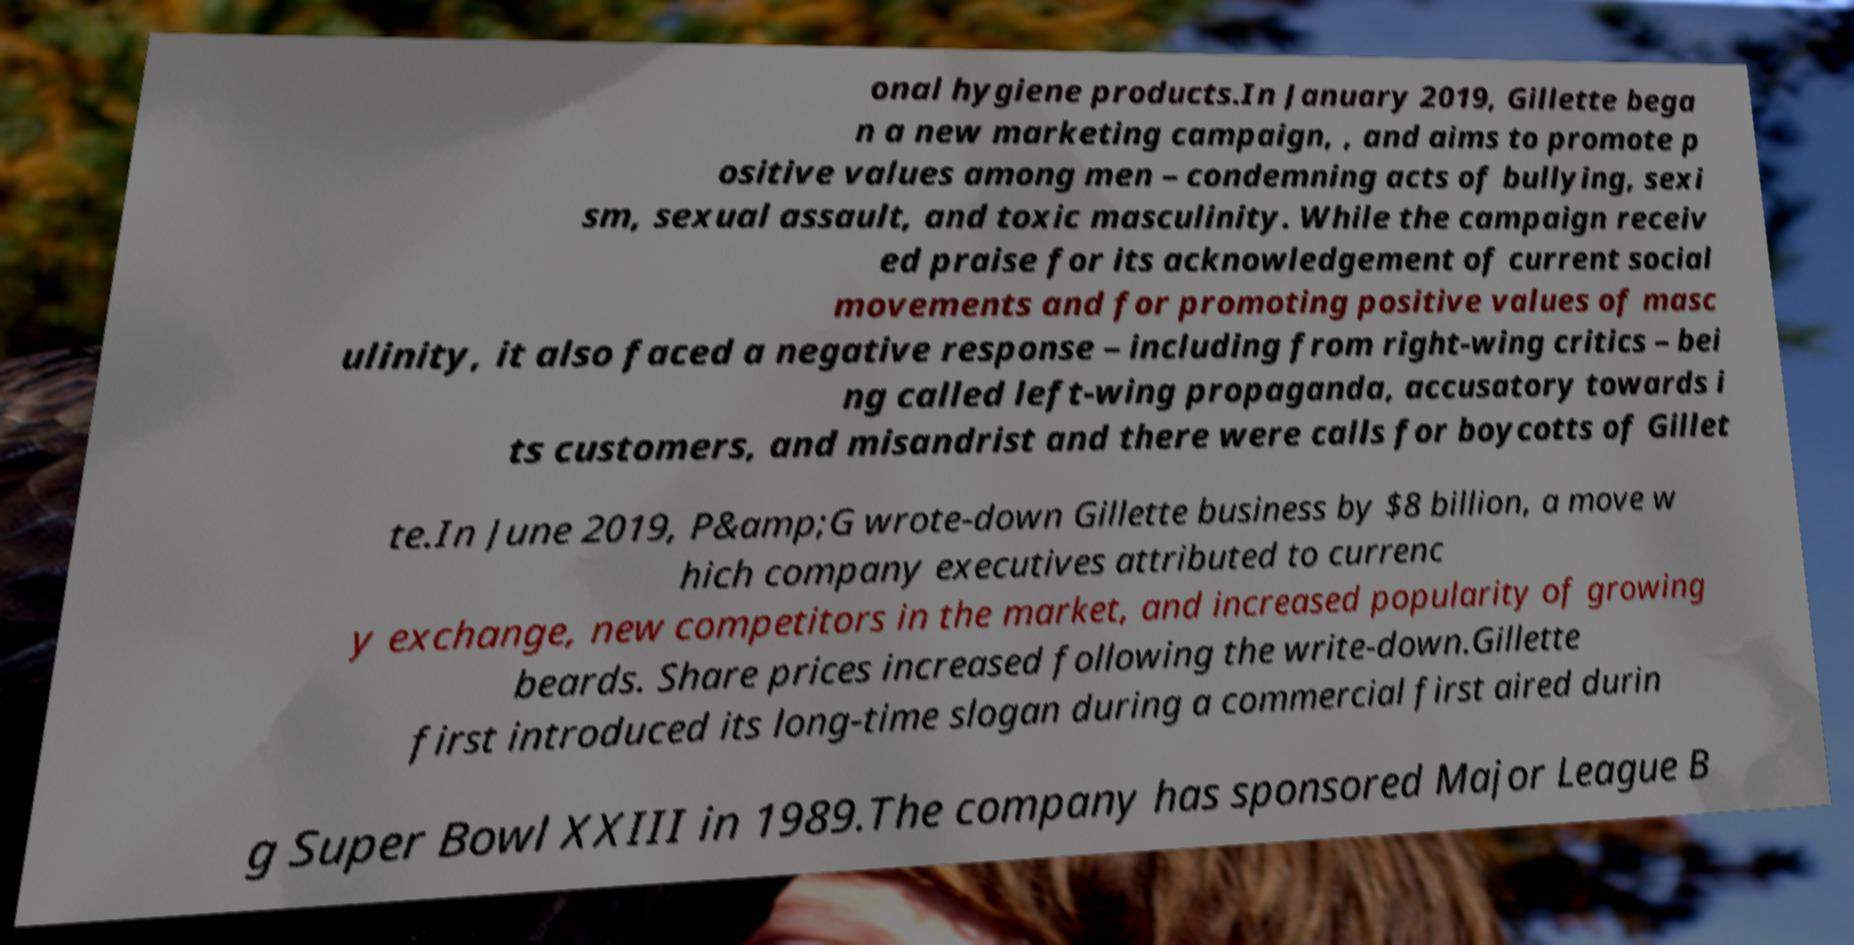Please read and relay the text visible in this image. What does it say? onal hygiene products.In January 2019, Gillette bega n a new marketing campaign, , and aims to promote p ositive values among men – condemning acts of bullying, sexi sm, sexual assault, and toxic masculinity. While the campaign receiv ed praise for its acknowledgement of current social movements and for promoting positive values of masc ulinity, it also faced a negative response – including from right-wing critics – bei ng called left-wing propaganda, accusatory towards i ts customers, and misandrist and there were calls for boycotts of Gillet te.In June 2019, P&amp;G wrote-down Gillette business by $8 billion, a move w hich company executives attributed to currenc y exchange, new competitors in the market, and increased popularity of growing beards. Share prices increased following the write-down.Gillette first introduced its long-time slogan during a commercial first aired durin g Super Bowl XXIII in 1989.The company has sponsored Major League B 